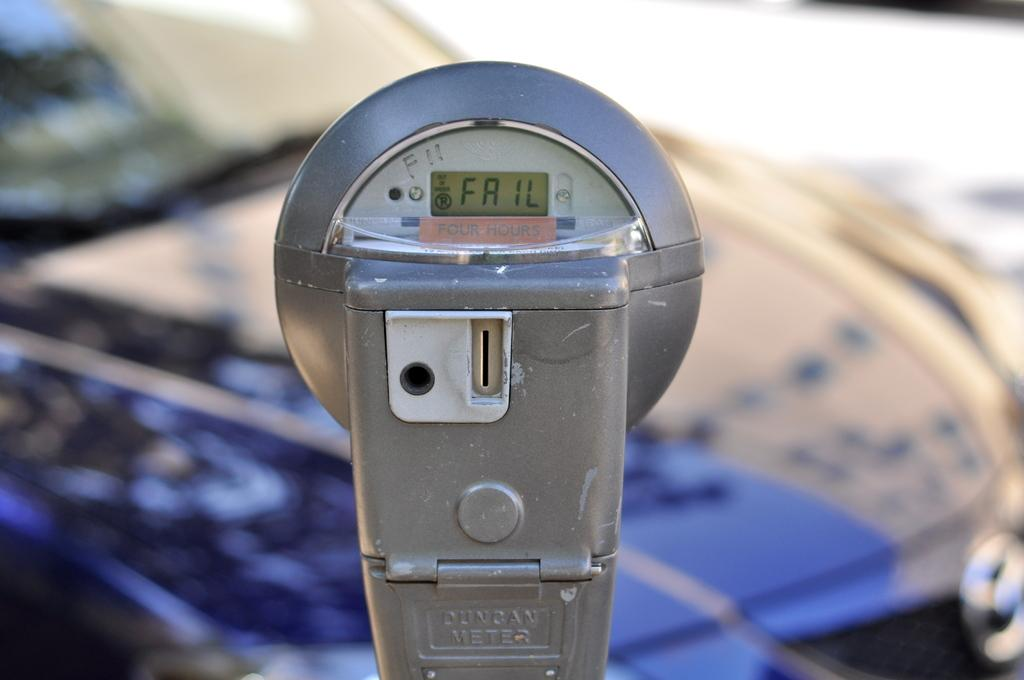<image>
Share a concise interpretation of the image provided. A parking meter displays a fail message on a sunny day. 